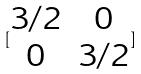Convert formula to latex. <formula><loc_0><loc_0><loc_500><loc_500>[ \begin{matrix} 3 / 2 & 0 \\ 0 & 3 / 2 \end{matrix} ]</formula> 